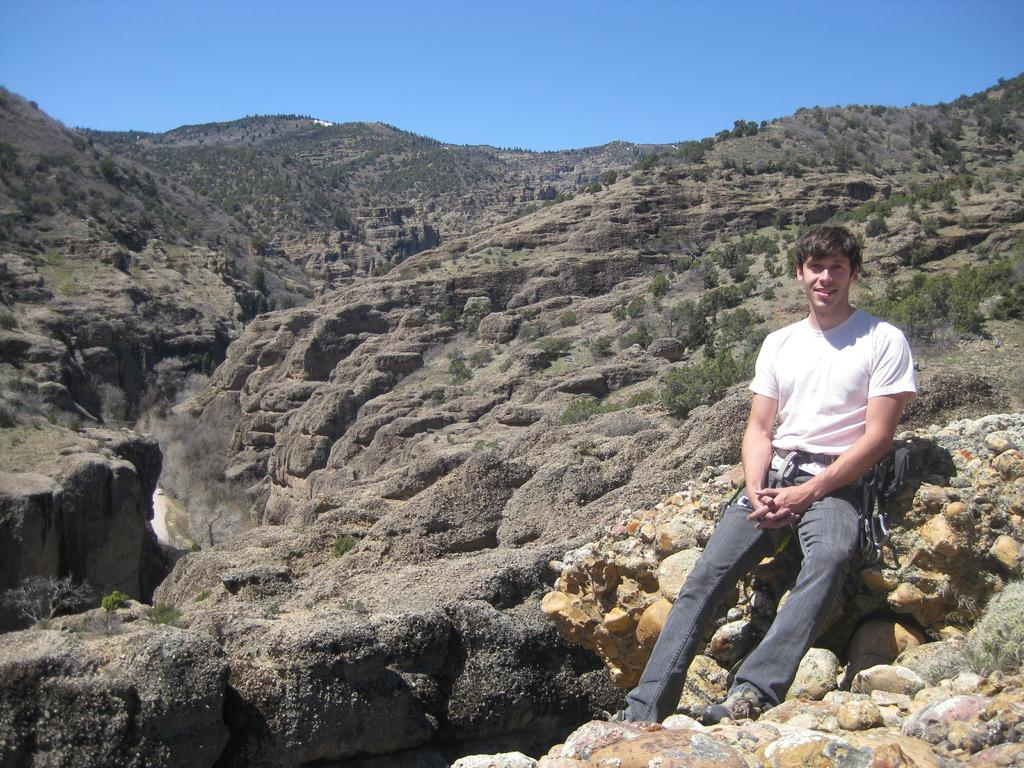What is the person in the image wearing? The person is wearing a white color T-shirt in the image. Where is the person sitting in the image? The person is sitting on a hill surface. What can be seen in the background of the image? There are mountains in the background of the image. What is the condition of the sky in the image? The sky is blue, and there are clouds visible. What type of lock is the person holding in the image? There is no lock present in the image; the person is sitting on a hill surface. What brand of toothpaste can be seen in the image? There is no toothpaste present in the image; it features a person sitting on a hill with mountains in the background. 